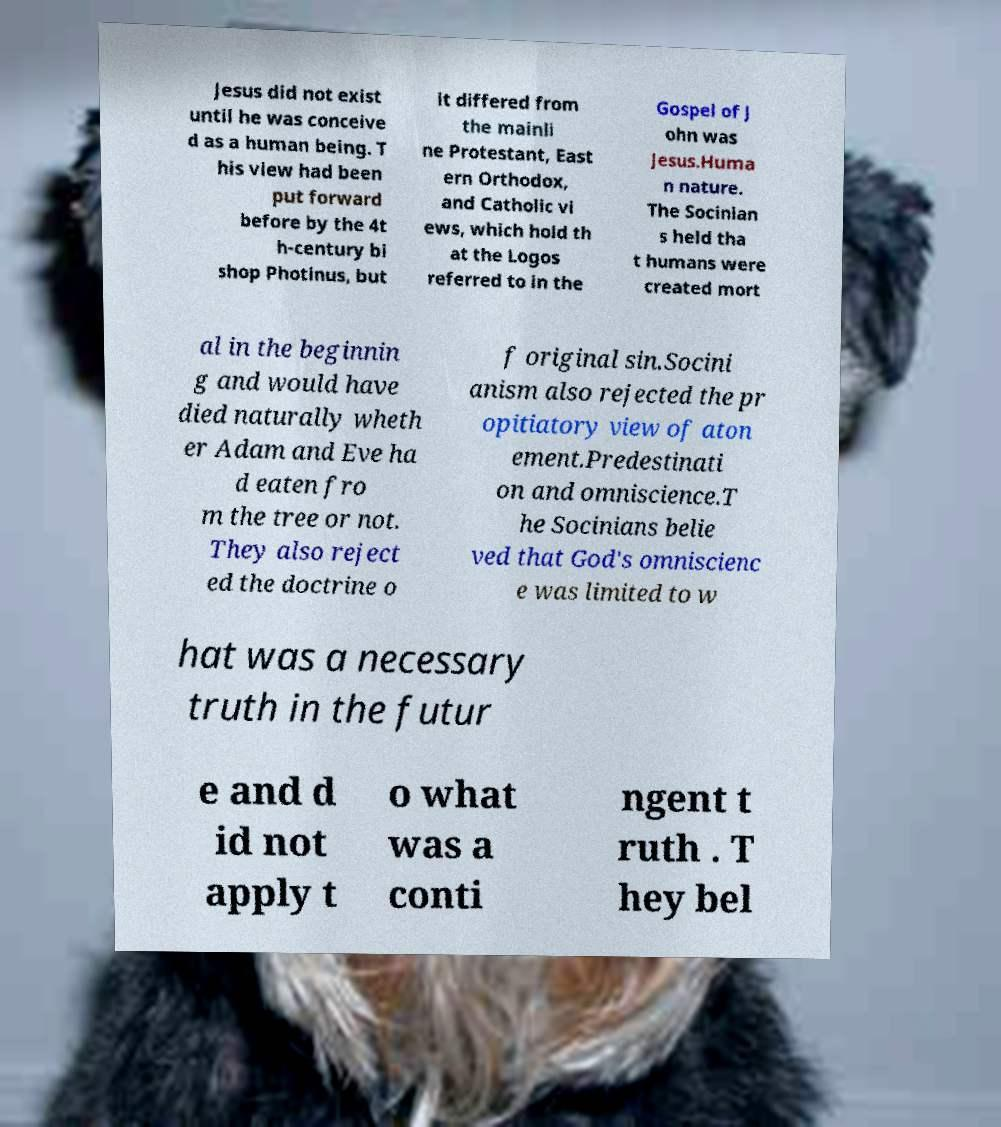Can you read and provide the text displayed in the image?This photo seems to have some interesting text. Can you extract and type it out for me? Jesus did not exist until he was conceive d as a human being. T his view had been put forward before by the 4t h-century bi shop Photinus, but it differed from the mainli ne Protestant, East ern Orthodox, and Catholic vi ews, which hold th at the Logos referred to in the Gospel of J ohn was Jesus.Huma n nature. The Socinian s held tha t humans were created mort al in the beginnin g and would have died naturally wheth er Adam and Eve ha d eaten fro m the tree or not. They also reject ed the doctrine o f original sin.Socini anism also rejected the pr opitiatory view of aton ement.Predestinati on and omniscience.T he Socinians belie ved that God's omniscienc e was limited to w hat was a necessary truth in the futur e and d id not apply t o what was a conti ngent t ruth . T hey bel 